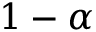Convert formula to latex. <formula><loc_0><loc_0><loc_500><loc_500>1 - \alpha</formula> 